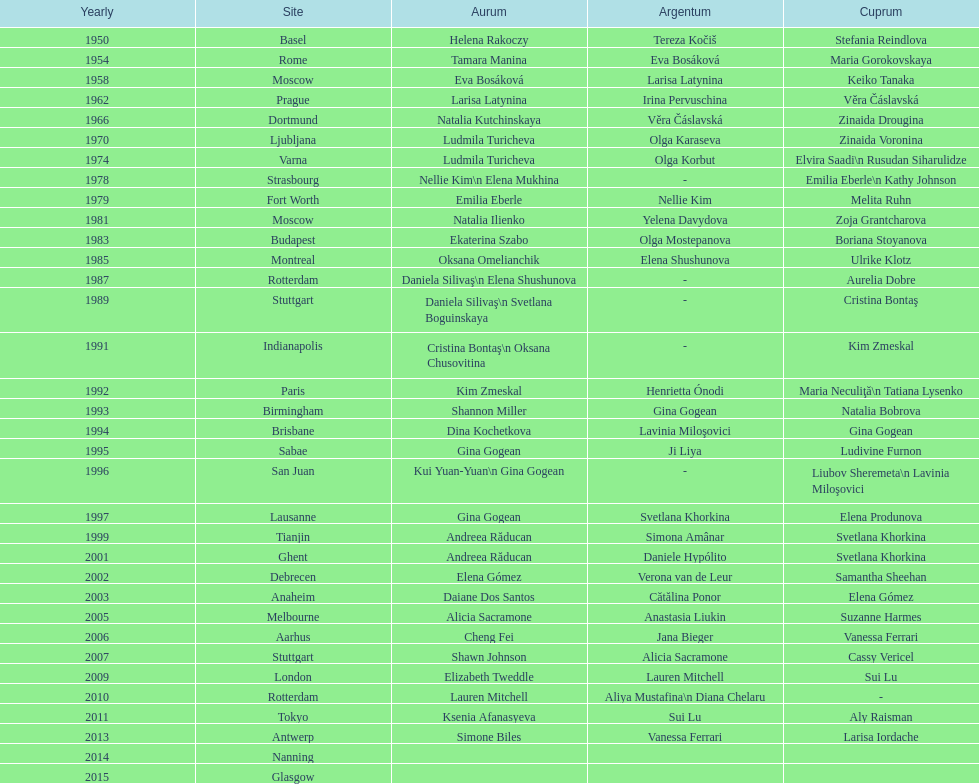How long is the time between the times the championship was held in moscow? 23 years. 